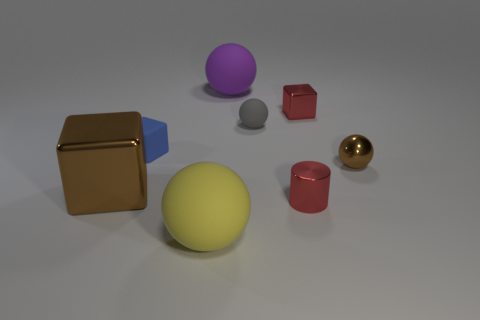The large object that is the same material as the small brown object is what shape?
Offer a very short reply. Cube. There is a brown metallic object that is on the left side of the gray sphere behind the rubber object that is in front of the small rubber cube; what shape is it?
Make the answer very short. Cube. Is the number of big purple rubber balls greater than the number of tiny rubber objects?
Your answer should be very brief. No. There is another large thing that is the same shape as the large purple rubber object; what is it made of?
Offer a terse response. Rubber. Are the large block and the big yellow ball made of the same material?
Your response must be concise. No. Are there more small blue blocks on the left side of the large brown thing than tiny gray balls?
Provide a short and direct response. No. What is the big object that is to the right of the big yellow object in front of the large rubber sphere that is behind the large brown shiny object made of?
Keep it short and to the point. Rubber. What number of objects are large shiny things or small cubes behind the red cylinder?
Your answer should be very brief. 3. There is a large ball in front of the brown metallic block; is it the same color as the metal sphere?
Give a very brief answer. No. Are there more large balls that are left of the red cube than gray matte balls that are to the right of the red shiny cylinder?
Your answer should be compact. Yes. 